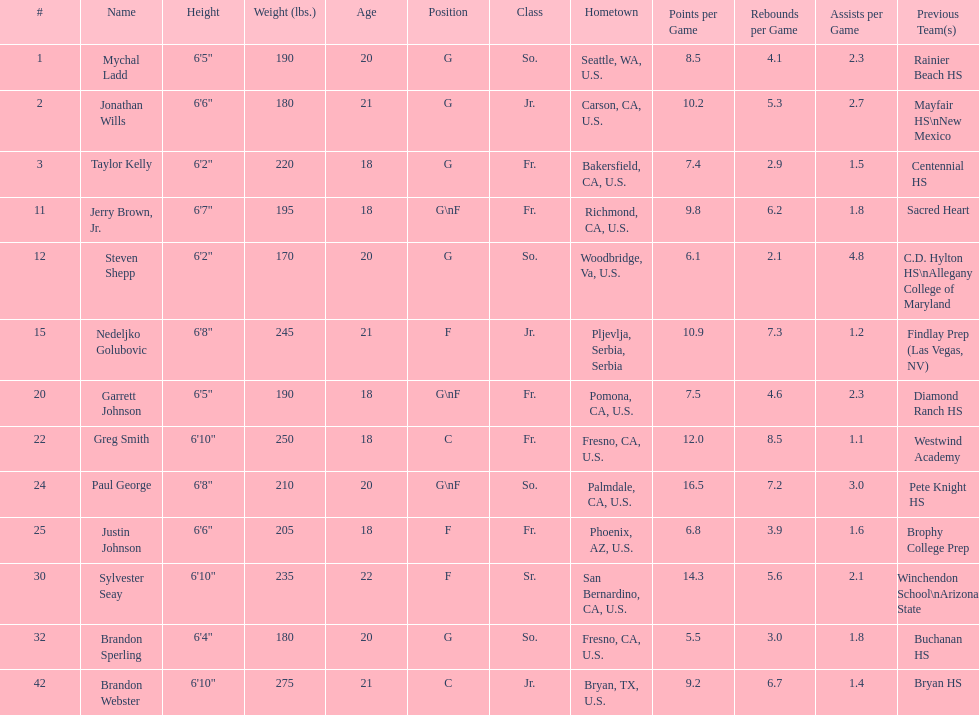How many players and both guard (g) and forward (f)? 3. 